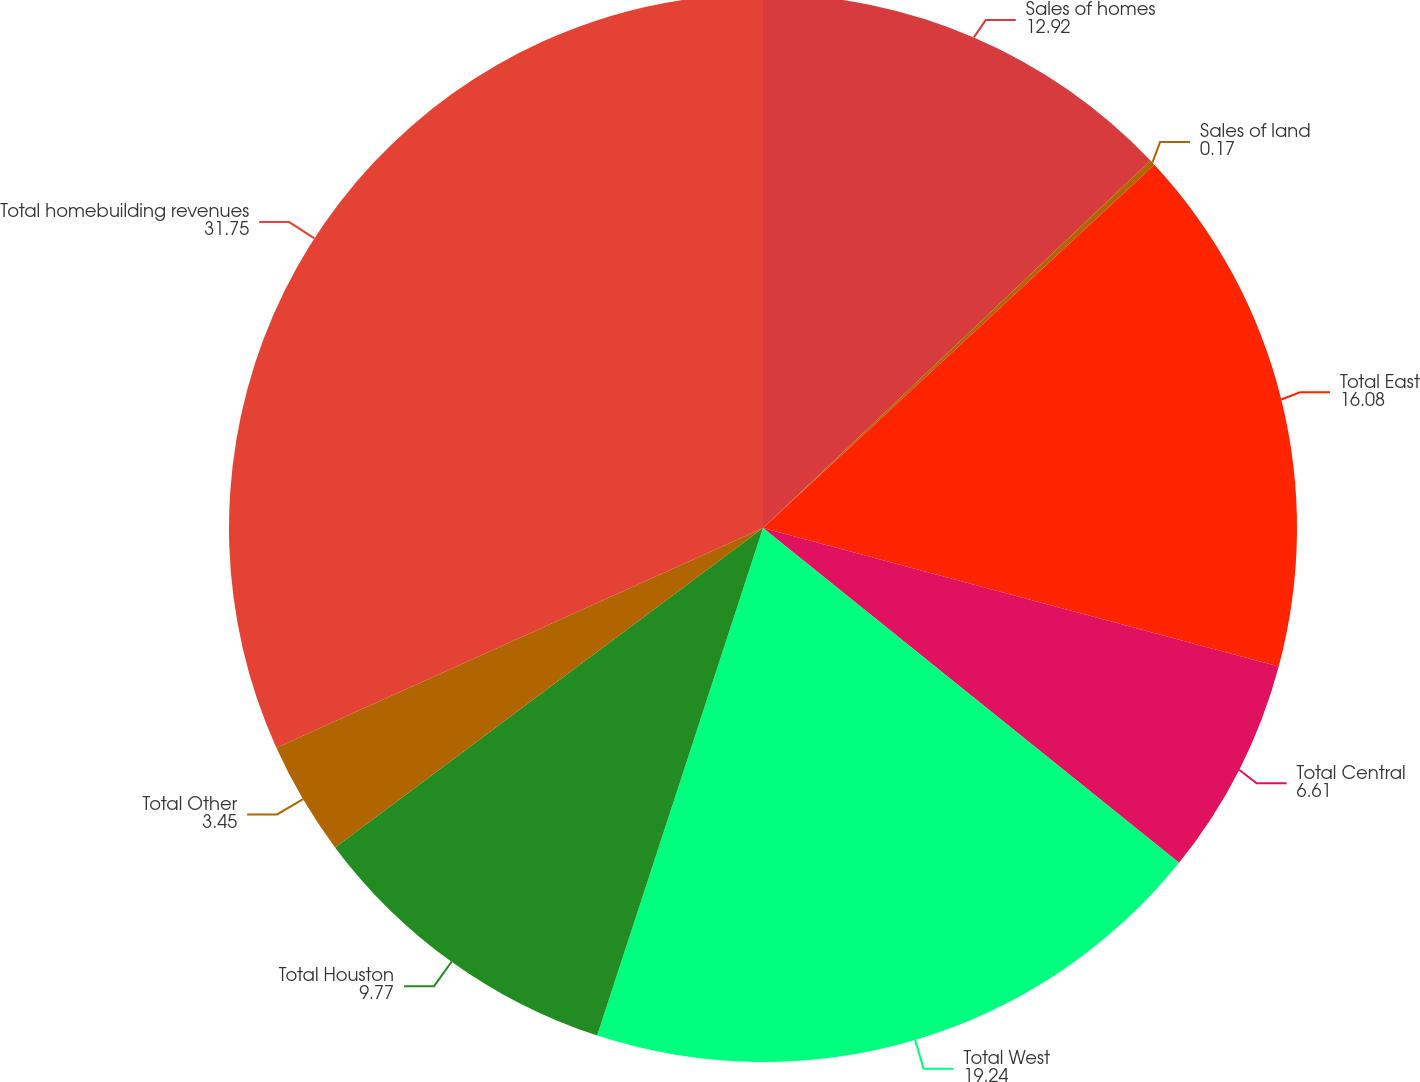<chart> <loc_0><loc_0><loc_500><loc_500><pie_chart><fcel>Sales of homes<fcel>Sales of land<fcel>Total East<fcel>Total Central<fcel>Total West<fcel>Total Houston<fcel>Total Other<fcel>Total homebuilding revenues<nl><fcel>12.92%<fcel>0.17%<fcel>16.08%<fcel>6.61%<fcel>19.24%<fcel>9.77%<fcel>3.45%<fcel>31.75%<nl></chart> 